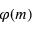Convert formula to latex. <formula><loc_0><loc_0><loc_500><loc_500>\varphi ( m )</formula> 